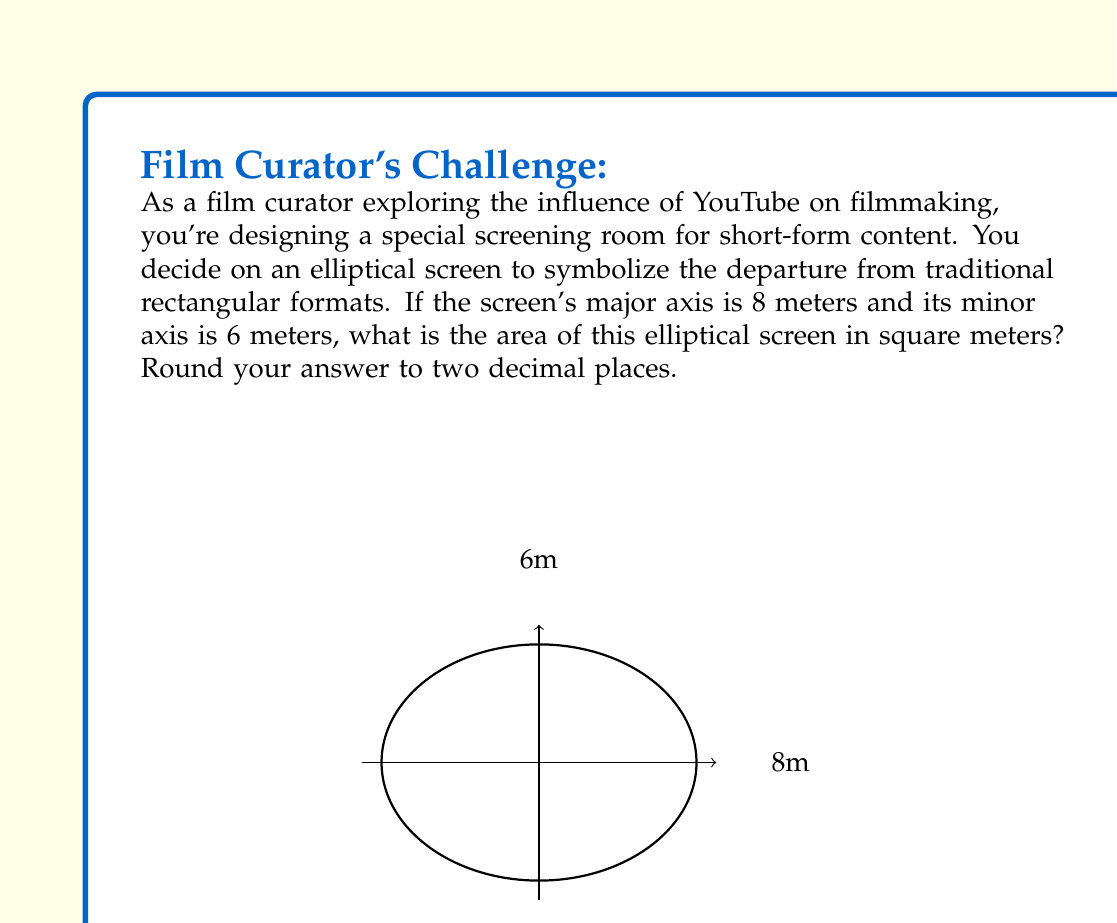Show me your answer to this math problem. To solve this problem, we'll use the formula for the area of an ellipse:

$$A = \pi ab$$

Where:
$A$ is the area of the ellipse
$a$ is half the length of the major axis
$b$ is half the length of the minor axis

Given:
- Major axis = 8 meters
- Minor axis = 6 meters

Step 1: Calculate $a$ and $b$
$a = 8 \div 2 = 4$ meters
$b = 6 \div 2 = 3$ meters

Step 2: Apply the formula
$$A = \pi ab$$
$$A = \pi \cdot 4 \cdot 3$$
$$A = 12\pi$$

Step 3: Calculate the result
$$A \approx 12 \cdot 3.14159...$$
$$A \approx 37.69911...$$

Step 4: Round to two decimal places
$$A \approx 37.70$$ square meters
Answer: $37.70$ m² 